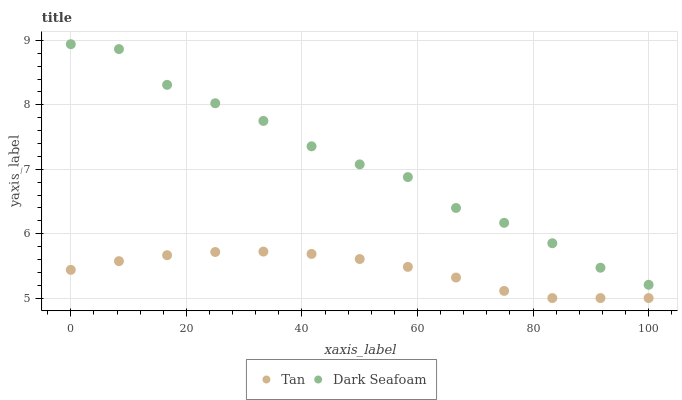Does Tan have the minimum area under the curve?
Answer yes or no. Yes. Does Dark Seafoam have the maximum area under the curve?
Answer yes or no. Yes. Does Dark Seafoam have the minimum area under the curve?
Answer yes or no. No. Is Tan the smoothest?
Answer yes or no. Yes. Is Dark Seafoam the roughest?
Answer yes or no. Yes. Is Dark Seafoam the smoothest?
Answer yes or no. No. Does Tan have the lowest value?
Answer yes or no. Yes. Does Dark Seafoam have the lowest value?
Answer yes or no. No. Does Dark Seafoam have the highest value?
Answer yes or no. Yes. Is Tan less than Dark Seafoam?
Answer yes or no. Yes. Is Dark Seafoam greater than Tan?
Answer yes or no. Yes. Does Tan intersect Dark Seafoam?
Answer yes or no. No. 